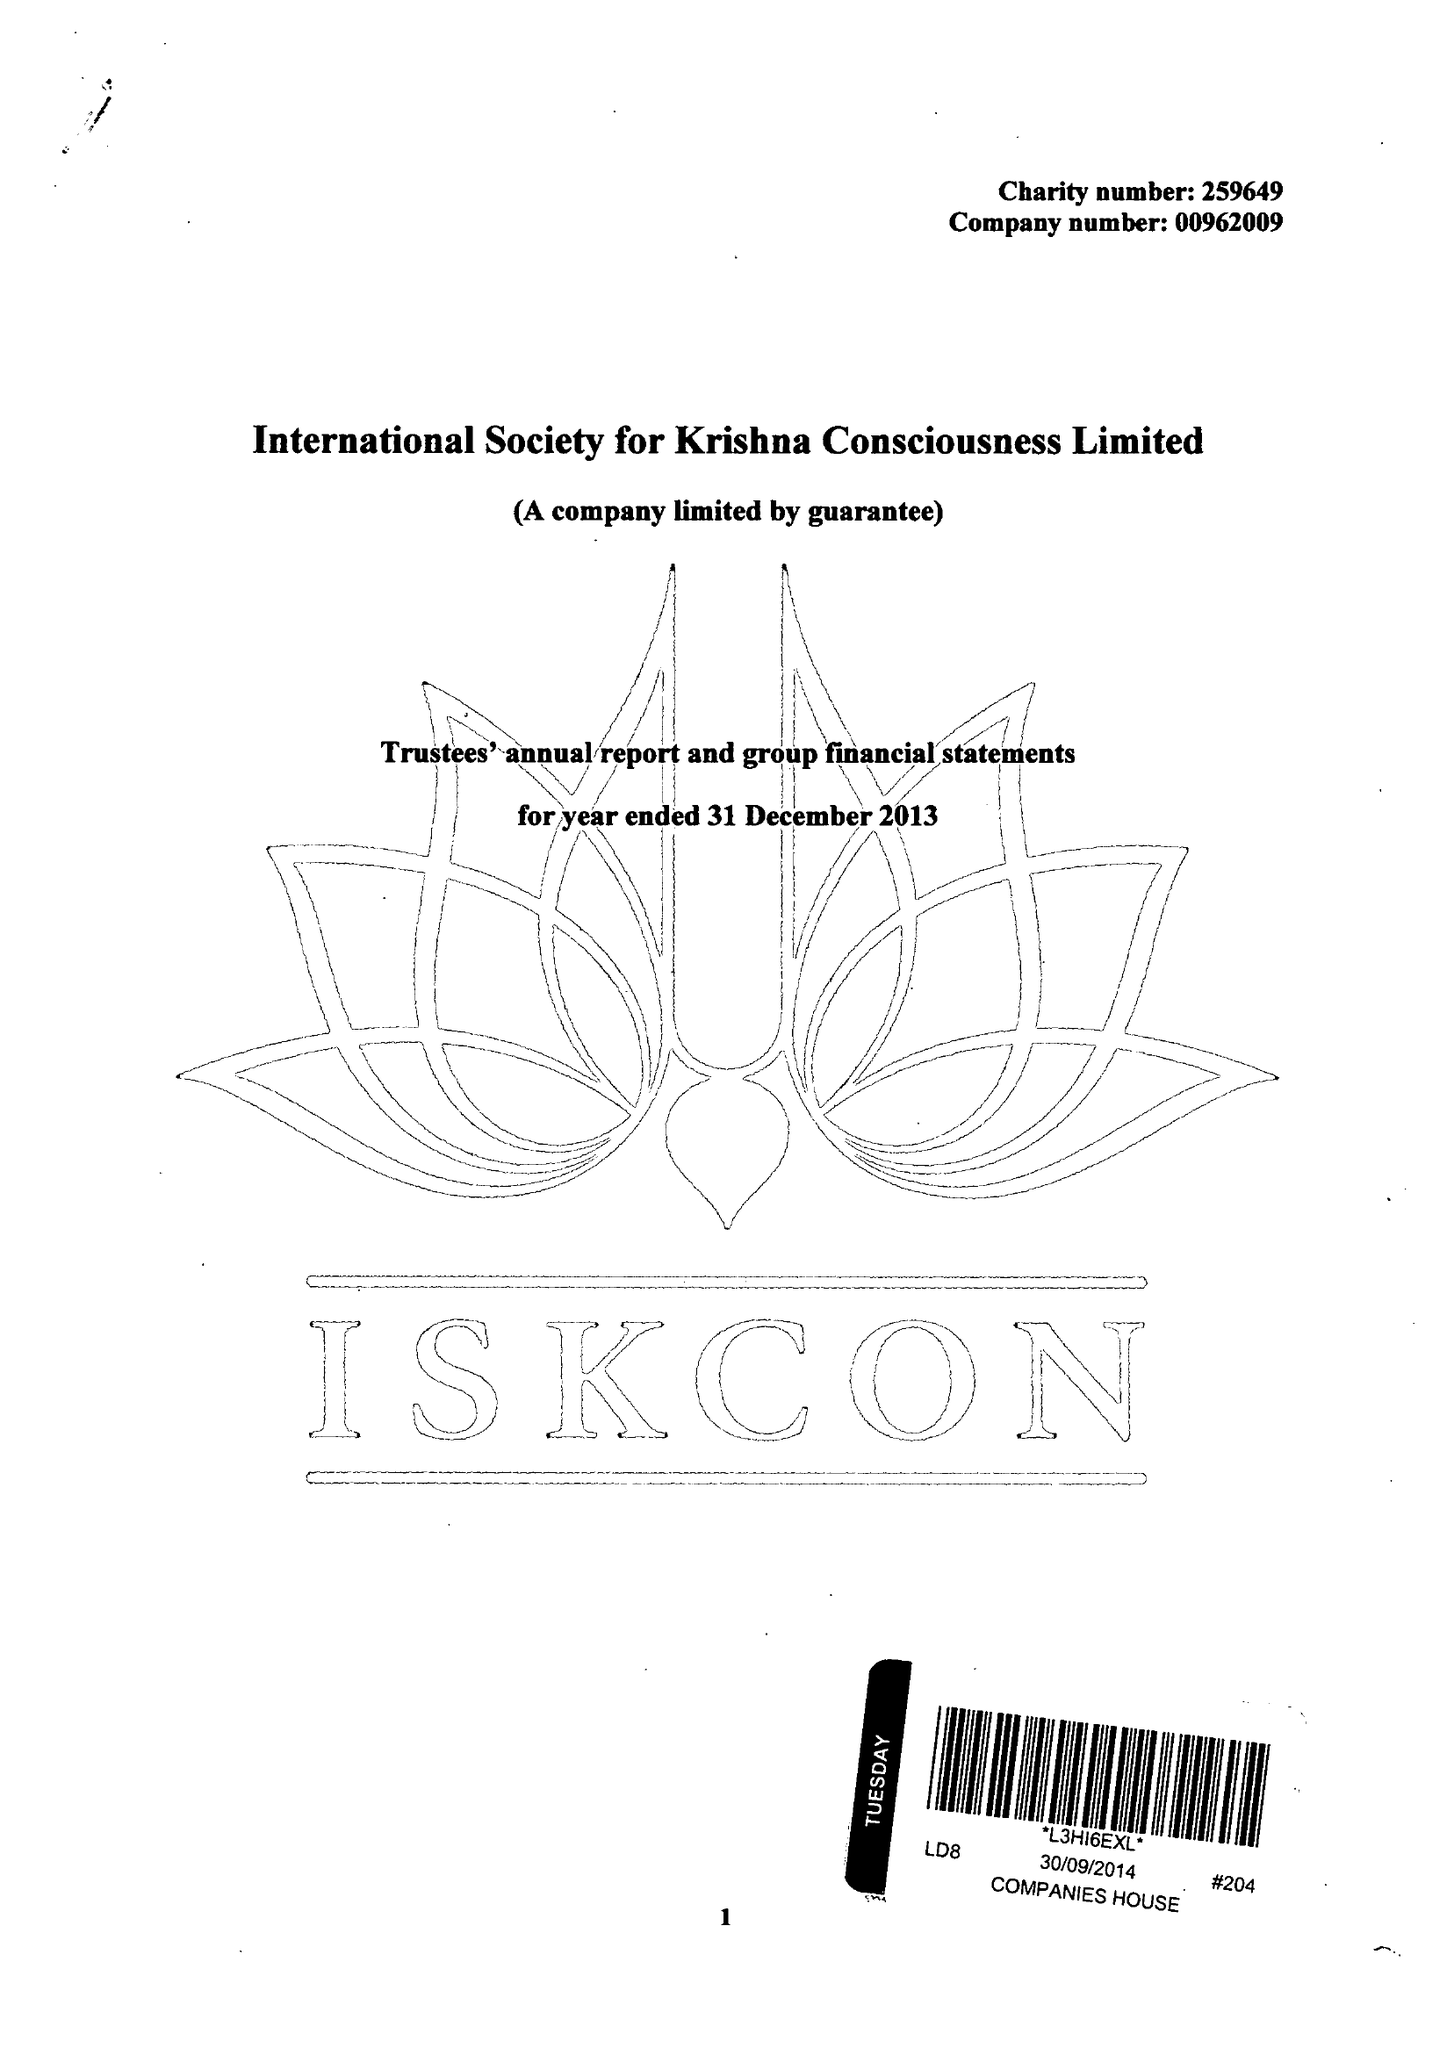What is the value for the report_date?
Answer the question using a single word or phrase. 2013-12-31 